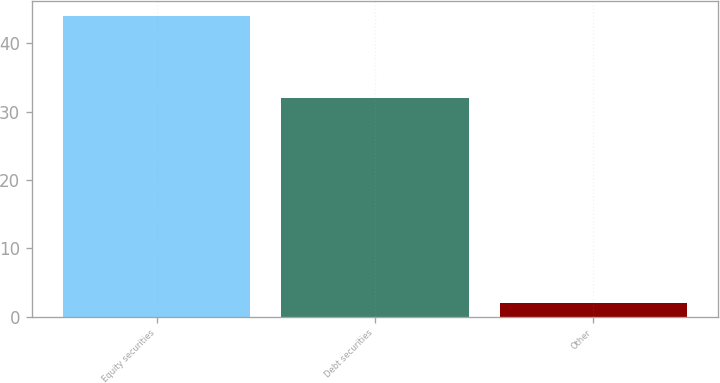<chart> <loc_0><loc_0><loc_500><loc_500><bar_chart><fcel>Equity securities<fcel>Debt securities<fcel>Other<nl><fcel>44<fcel>32<fcel>2<nl></chart> 